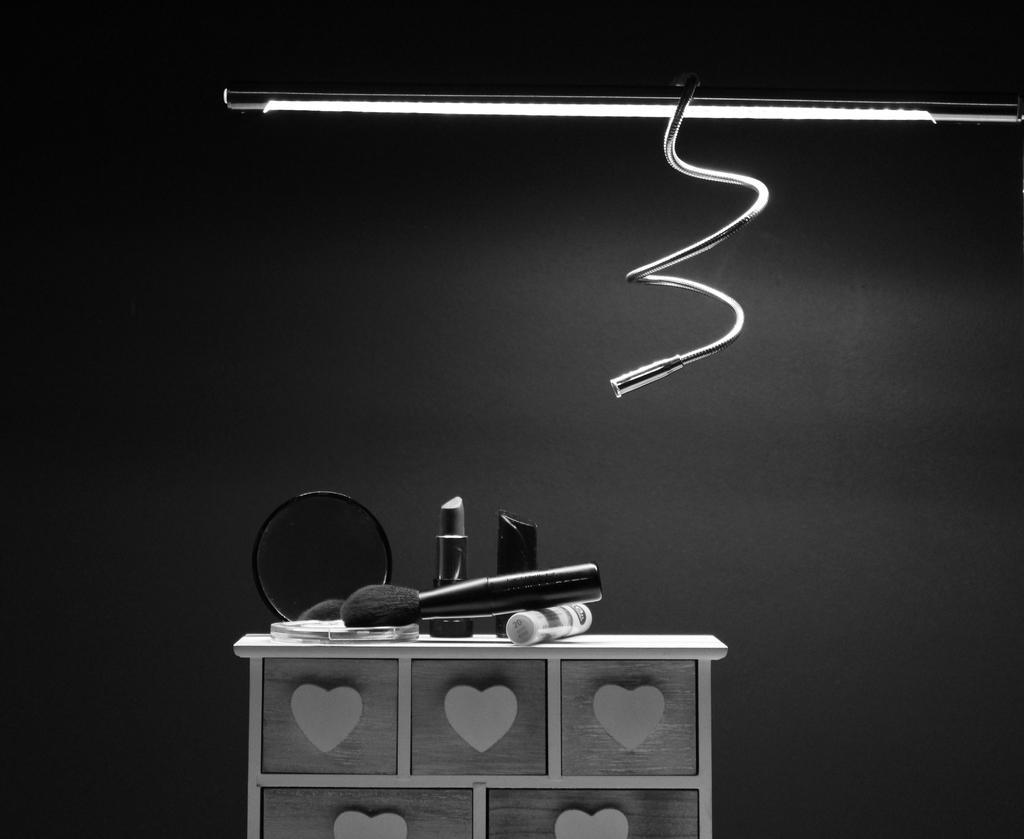Can you describe this image briefly? It is a black and white image. In this image we can see the mirror, makeup brush and also lipsticks on the top of the table. We can also see the light and also the wire. In the background there is a plain wall. 